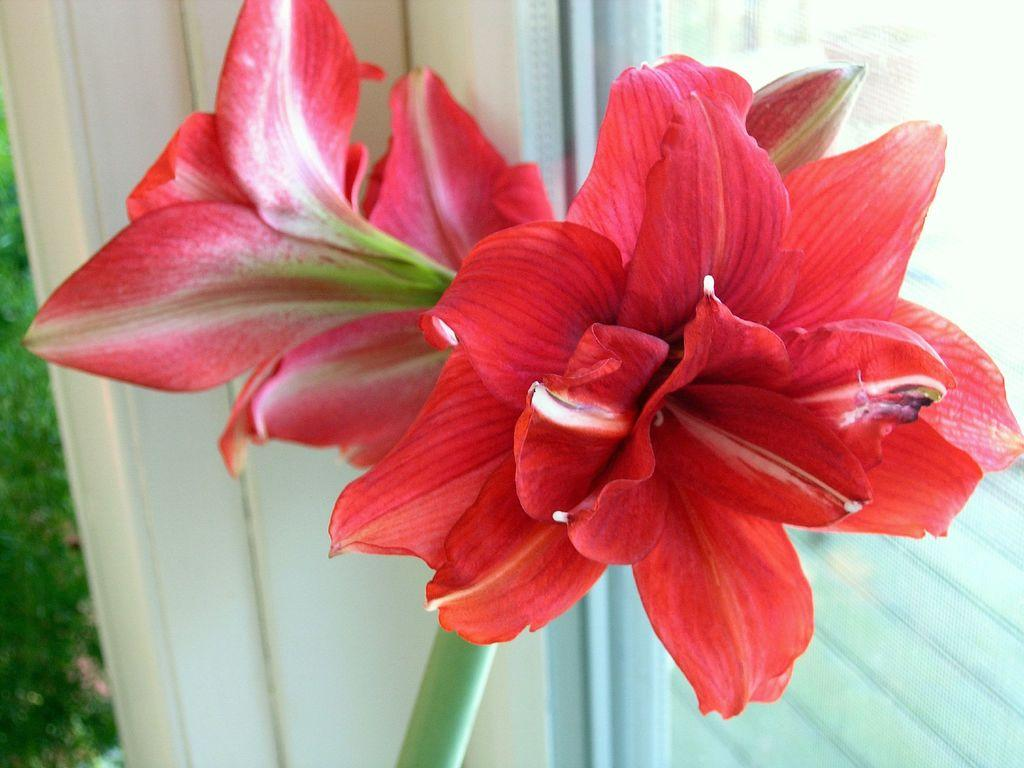What type of flowers can be seen in the image? There are red color flowers in the image. Where are the flowers located in relation to other elements in the image? The flowers are placed near the glass windows. What color is present on the left side of the image? The left side of the image has a green color. What flavor of ice cream is being served with a fork in the image? There is no ice cream or fork present in the image; it features red color flowers near glass windows. 